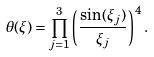Convert formula to latex. <formula><loc_0><loc_0><loc_500><loc_500>\theta ( \xi ) = \prod _ { j = 1 } ^ { 3 } \left ( \frac { \sin ( \xi _ { j } ) } { \xi _ { j } } \right ) ^ { 4 } .</formula> 